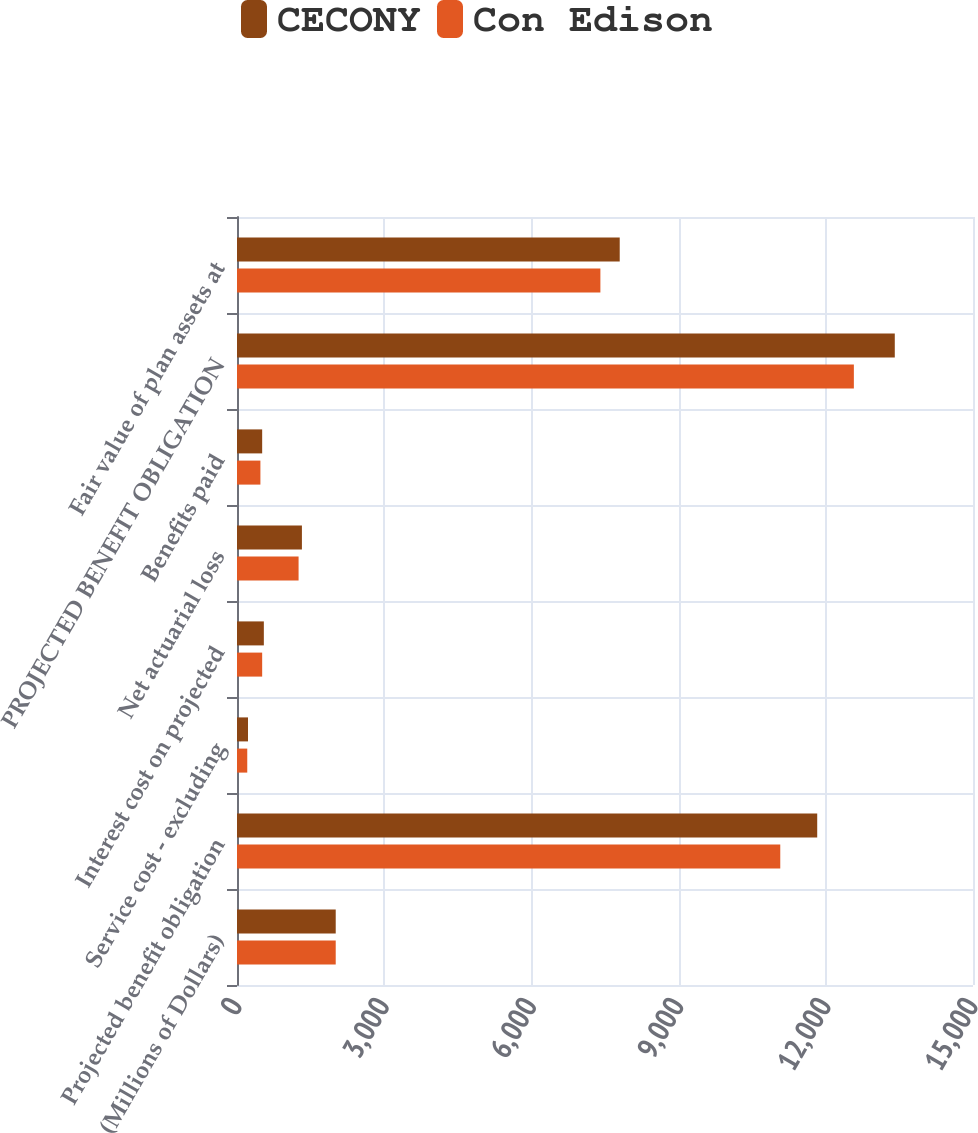Convert chart to OTSL. <chart><loc_0><loc_0><loc_500><loc_500><stacked_bar_chart><ecel><fcel>(Millions of Dollars)<fcel>Projected benefit obligation<fcel>Service cost - excluding<fcel>Interest cost on projected<fcel>Net actuarial loss<fcel>Benefits paid<fcel>PROJECTED BENEFIT OBLIGATION<fcel>Fair value of plan assets at<nl><fcel>CECONY<fcel>2012<fcel>11825<fcel>224<fcel>547<fcel>1323<fcel>513<fcel>13406<fcel>7800<nl><fcel>Con Edison<fcel>2012<fcel>11072<fcel>209<fcel>513<fcel>1255<fcel>477<fcel>12572<fcel>7406<nl></chart> 